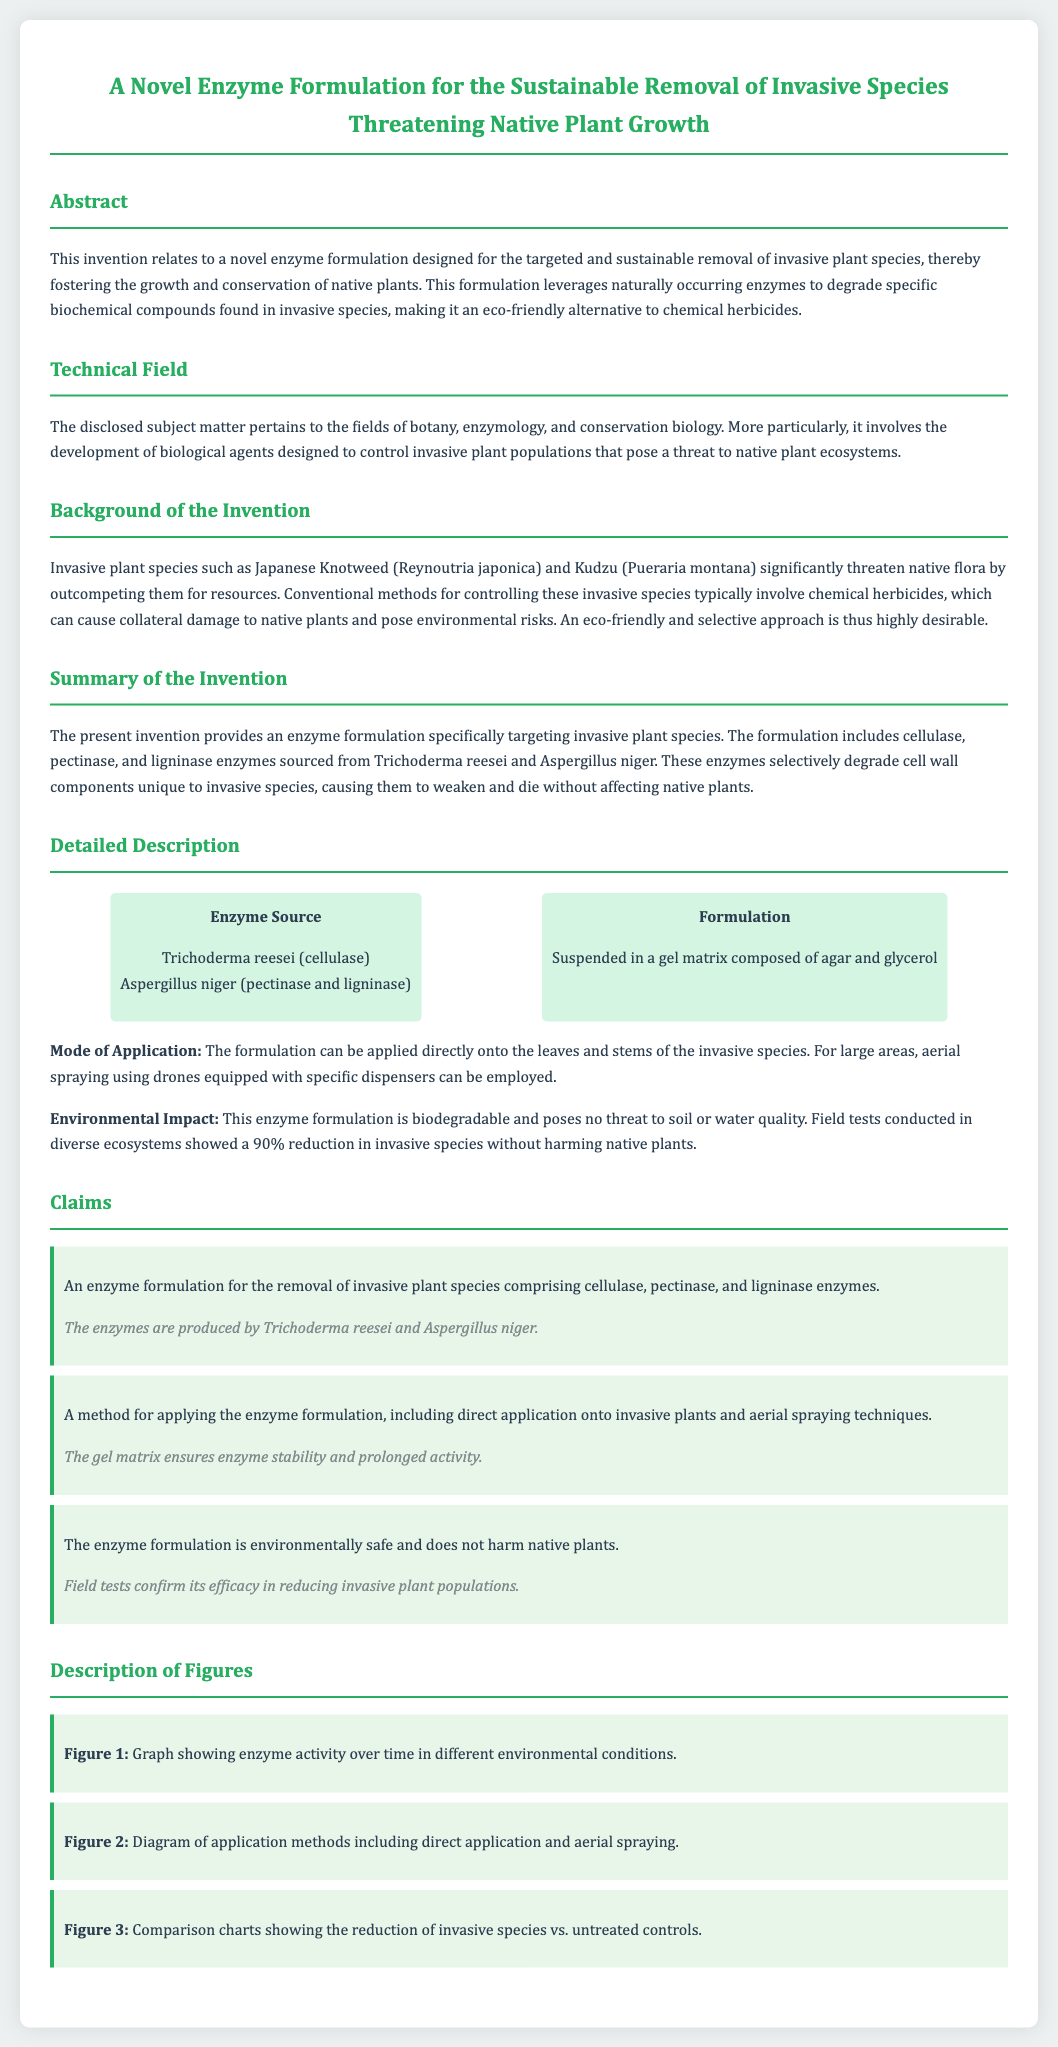What is the purpose of the invention? The invention is designed for the targeted and sustainable removal of invasive plant species, fostering the growth and conservation of native plants.
Answer: sustainable removal of invasive species What enzymes are included in the formulation? The formulation includes cellulase, pectinase, and ligninase enzymes.
Answer: cellulase, pectinase, and ligninase Who are the enzyme sources mentioned in the document? The enzymes are sourced from Trichoderma reesei and Aspergillus niger.
Answer: Trichoderma reesei and Aspergillus niger What method is proposed for applying the enzyme formulation? The formulation can be applied directly onto the leaves and stems of the invasive species and through aerial spraying.
Answer: direct application and aerial spraying What is the efficacy of the enzyme formulation according to field tests? Field tests showed a 90% reduction in invasive species without harming native plants.
Answer: 90% reduction What is the environmental impact of the enzyme formulation? The enzyme formulation is biodegradable and poses no threat to soil or water quality.
Answer: biodegradable and poses no threat Which invasive plant species are specifically mentioned in the background? Japanese Knotweed and Kudzu are mentioned as invasive species that threaten native flora.
Answer: Japanese Knotweed and Kudzu What is the type of patent application? The document is a patent application related to a novel enzyme formulation.
Answer: patent application 